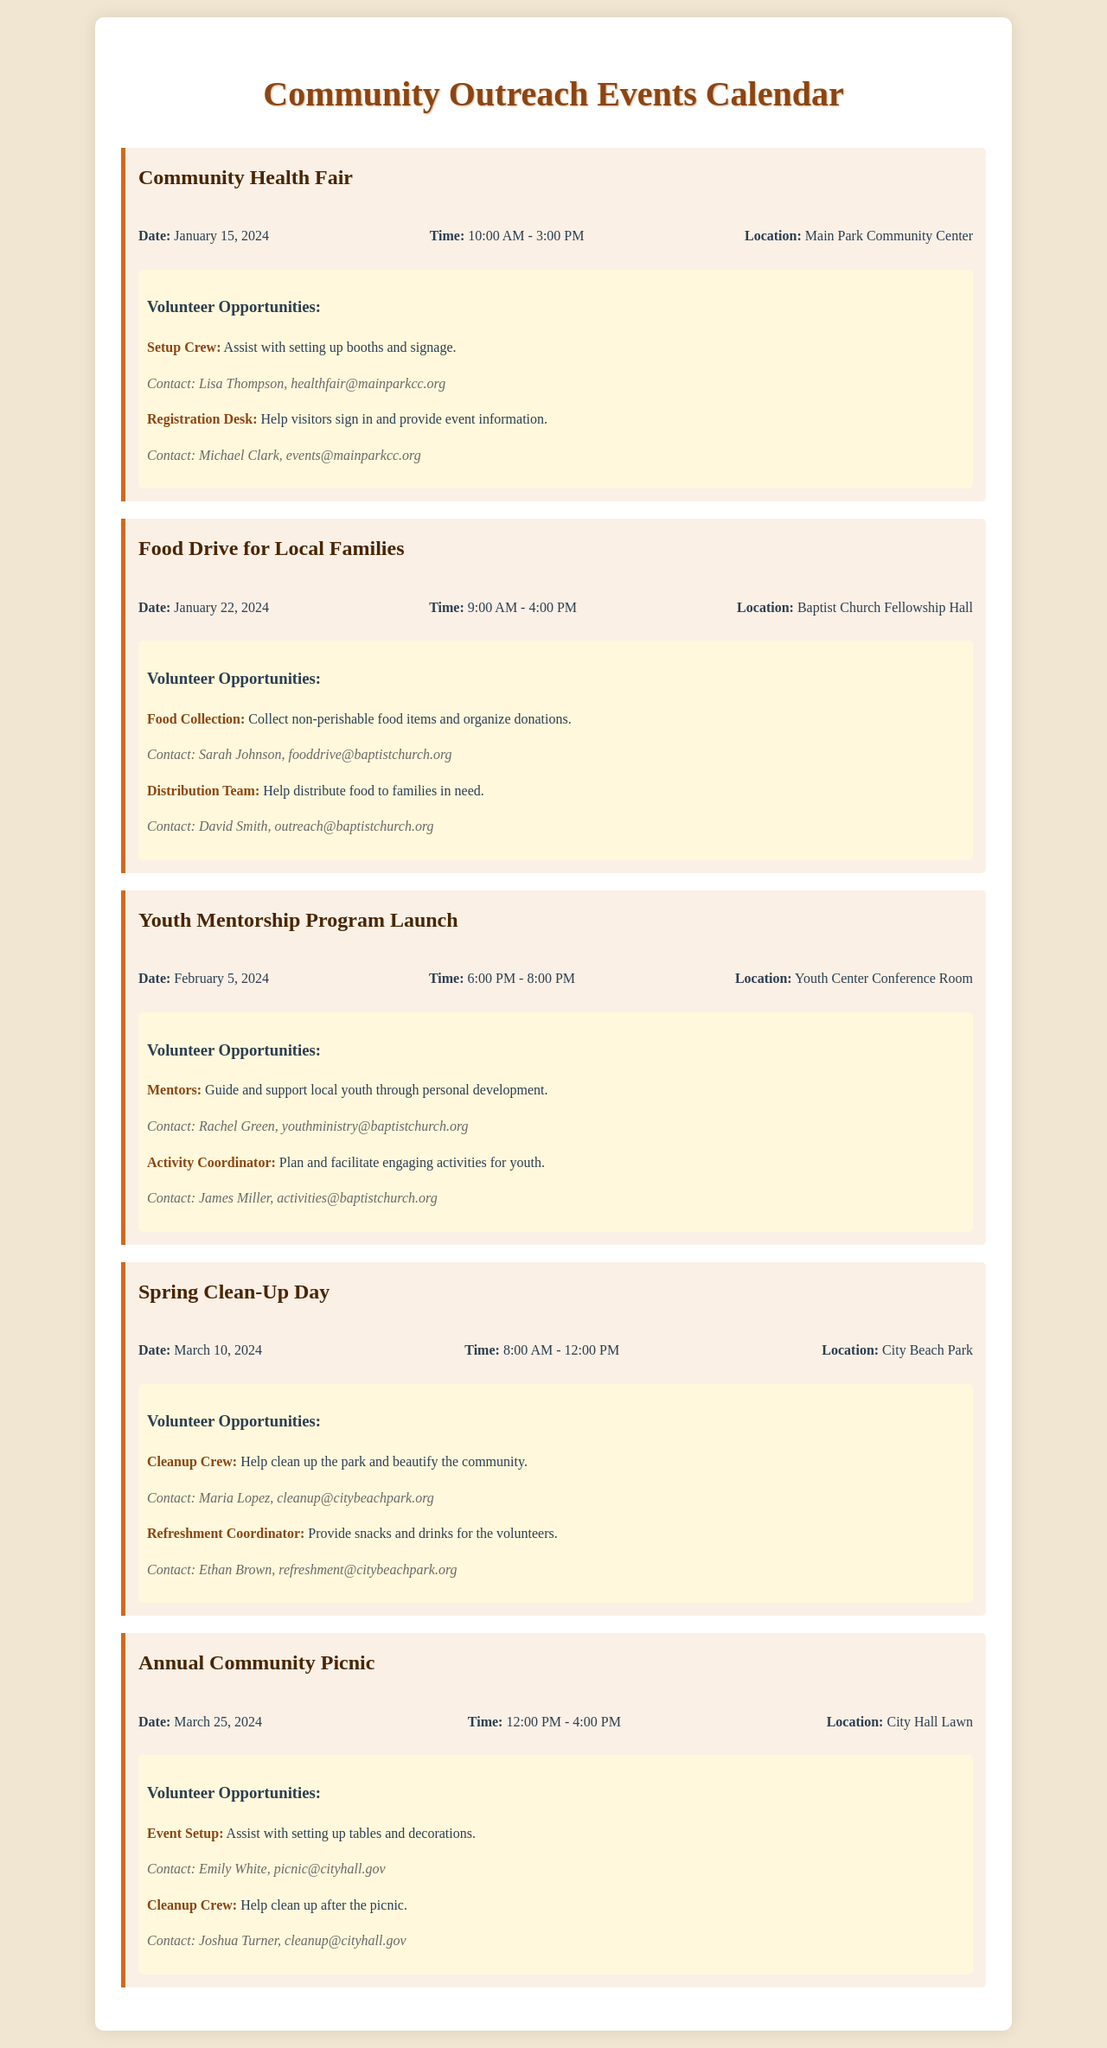What is the date of the Community Health Fair? The date of the Community Health Fair is specified in the document.
Answer: January 15, 2024 Where will the Food Drive for Local Families be held? The location for the Food Drive for Local Families is mentioned in the document.
Answer: Baptist Church Fellowship Hall Who should I contact for the Setup Crew at the Community Health Fair? The document lists a contact for the Setup Crew opportunity at this event.
Answer: Lisa Thompson What time does the Youth Mentorship Program Launch start? The starting time for the Youth Mentorship Program Launch is provided in the event details.
Answer: 6:00 PM What is the main activity for the Spring Clean-Up Day? The document describes the main purpose of the Spring Clean-Up Day event.
Answer: Clean up the park Which event is taking place on March 25, 2024? The specific event date helps identify which event is scheduled for this date.
Answer: Annual Community Picnic How many volunteer roles are listed for the Food Drive? The document details the number of distinct volunteer roles available for the Food Drive.
Answer: 2 What is the contact email for the Distribution Team at the Food Drive? The contact email for the Distribution Team is provided in the volunteer opportunities section.
Answer: outreach@baptistchurch.org 